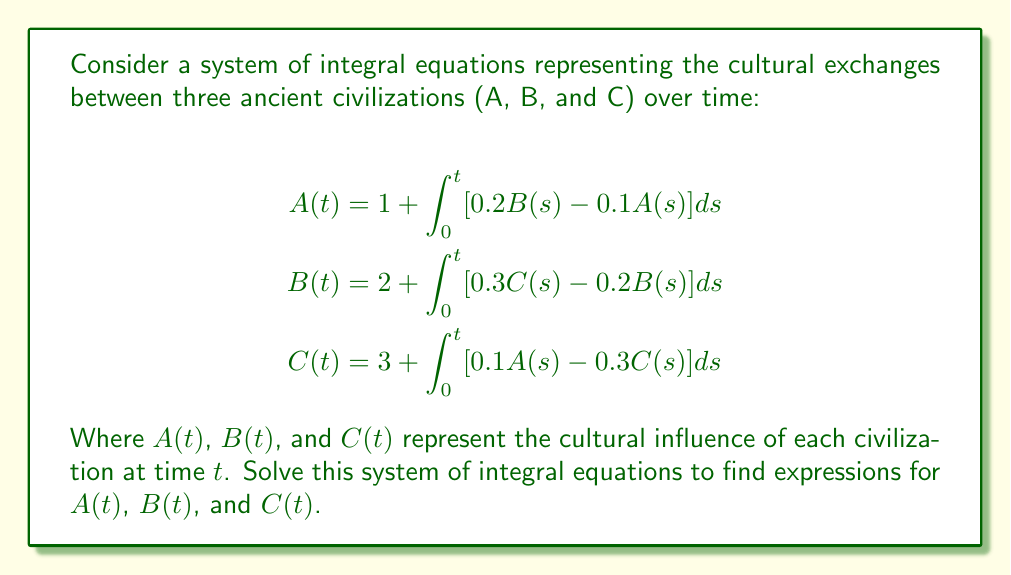Can you solve this math problem? To solve this system of integral equations, we'll follow these steps:

1) First, we differentiate both sides of each equation with respect to $t$:

   $$\begin{align}
   A'(t) &= 0.2B(t) - 0.1A(t) \\
   B'(t) &= 0.3C(t) - 0.2B(t) \\
   C'(t) &= 0.1A(t) - 0.3C(t)
   \end{align}$$

2) Now we have a system of linear differential equations. We can write this in matrix form:

   $$\begin{pmatrix} A'(t) \\ B'(t) \\ C'(t) \end{pmatrix} = 
   \begin{pmatrix} 
   -0.1 & 0.2 & 0 \\
   0 & -0.2 & 0.3 \\
   0.1 & 0 & -0.3
   \end{pmatrix}
   \begin{pmatrix} A(t) \\ B(t) \\ C(t) \end{pmatrix}$$

3) Let's call the matrix $M$. To solve this, we need to find the eigenvalues and eigenvectors of $M$.

4) The characteristic equation is:
   
   $$det(M - \lambda I) = -(\lambda + 0.1)(\lambda + 0.2)(\lambda + 0.3) - 0.006 = 0$$

5) Solving this, we get the eigenvalues: $\lambda_1 = 0$, $\lambda_2 \approx -0.4472$, $\lambda_3 \approx -0.1528$

6) For each eigenvalue, we find the corresponding eigenvector:

   For $\lambda_1 = 0$: $v_1 = (3, 2, 1)^T$
   For $\lambda_2 \approx -0.4472$: $v_2 \approx (0.4472, -0.7746, 0.4472)^T$
   For $\lambda_3 \approx -0.1528$: $v_3 \approx (-0.8165, 0, 0.5774)^T$

7) The general solution is:

   $$\begin{pmatrix} A(t) \\ B(t) \\ C(t) \end{pmatrix} = 
   c_1 v_1 + c_2 e^{\lambda_2 t} v_2 + c_3 e^{\lambda_3 t} v_3$$

8) To find $c_1$, $c_2$, and $c_3$, we use the initial conditions:

   $$\begin{align}
   A(0) &= 1 \\
   B(0) &= 2 \\
   C(0) &= 3
   \end{align}$$

9) Solving this system, we get:

   $$\begin{align}
   c_1 &= 2 \\
   c_2 &\approx -0.5528 \\
   c_3 &\approx -0.4472
   \end{align}$$

10) Therefore, the final solution is:

    $$\begin{align}
    A(t) &\approx 6 - 0.2472e^{-0.4472t} - 0.3651e^{-0.1528t} \\
    B(t) &\approx 4 + 0.4282e^{-0.4472t} \\
    C(t) &\approx 2 - 0.2472e^{-0.4472t} + 0.2582e^{-0.1528t}
    \end{align}$$
Answer: $$\begin{align}
A(t) &\approx 6 - 0.2472e^{-0.4472t} - 0.3651e^{-0.1528t} \\
B(t) &\approx 4 + 0.4282e^{-0.4472t} \\
C(t) &\approx 2 - 0.2472e^{-0.4472t} + 0.2582e^{-0.1528t}
\end{align}$$ 